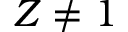<formula> <loc_0><loc_0><loc_500><loc_500>Z \neq 1</formula> 